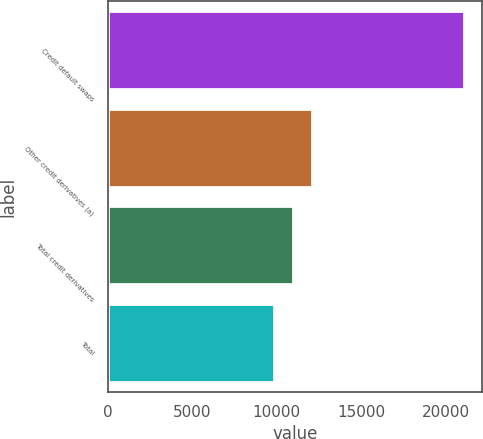Convert chart to OTSL. <chart><loc_0><loc_0><loc_500><loc_500><bar_chart><fcel>Credit default swaps<fcel>Other credit derivatives (a)<fcel>Total credit derivatives<fcel>Total<nl><fcel>21114<fcel>12095.6<fcel>10968.3<fcel>9841<nl></chart> 